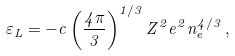Convert formula to latex. <formula><loc_0><loc_0><loc_500><loc_500>\varepsilon _ { L } = - c \left ( \frac { 4 \pi } { 3 } \right ) ^ { 1 / 3 } Z ^ { 2 } e ^ { 2 } n _ { e } ^ { 4 / 3 } \, ,</formula> 